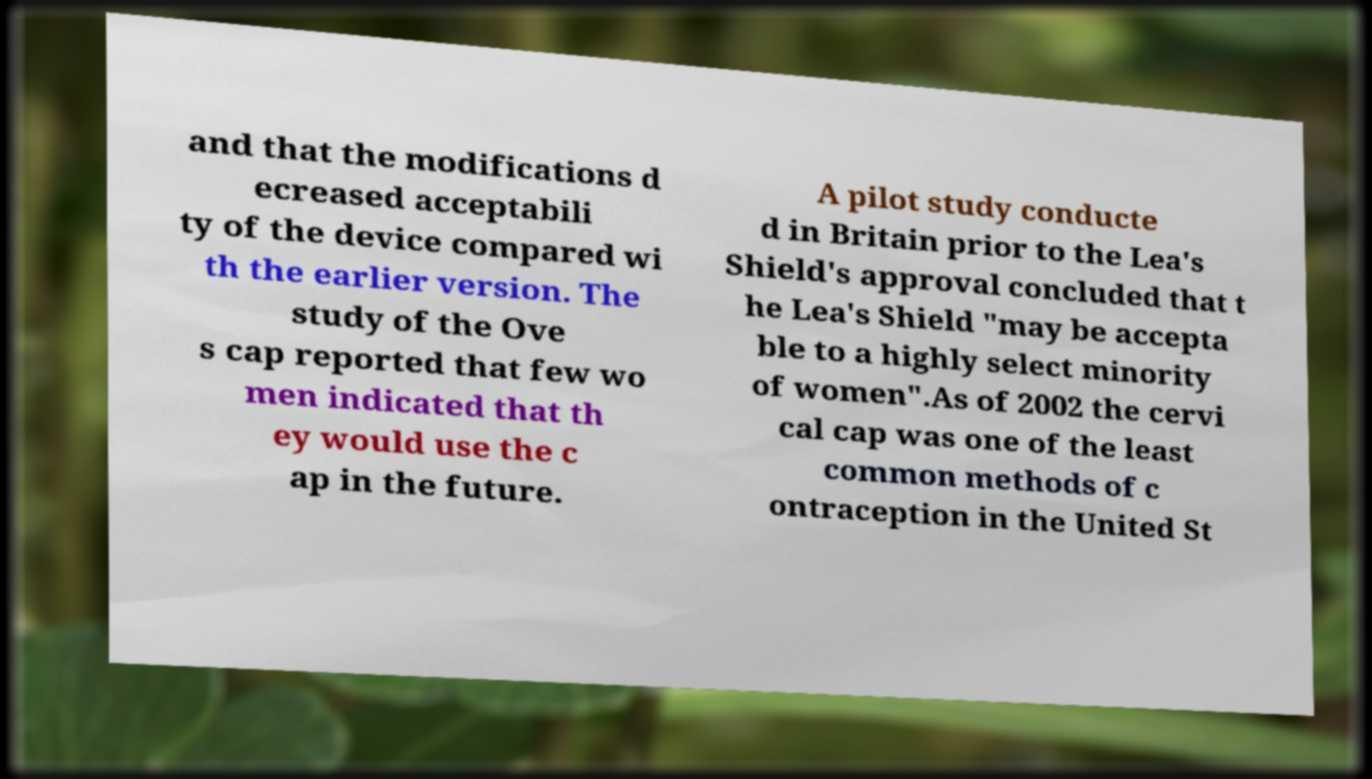What messages or text are displayed in this image? I need them in a readable, typed format. and that the modifications d ecreased acceptabili ty of the device compared wi th the earlier version. The study of the Ove s cap reported that few wo men indicated that th ey would use the c ap in the future. A pilot study conducte d in Britain prior to the Lea's Shield's approval concluded that t he Lea's Shield "may be accepta ble to a highly select minority of women".As of 2002 the cervi cal cap was one of the least common methods of c ontraception in the United St 